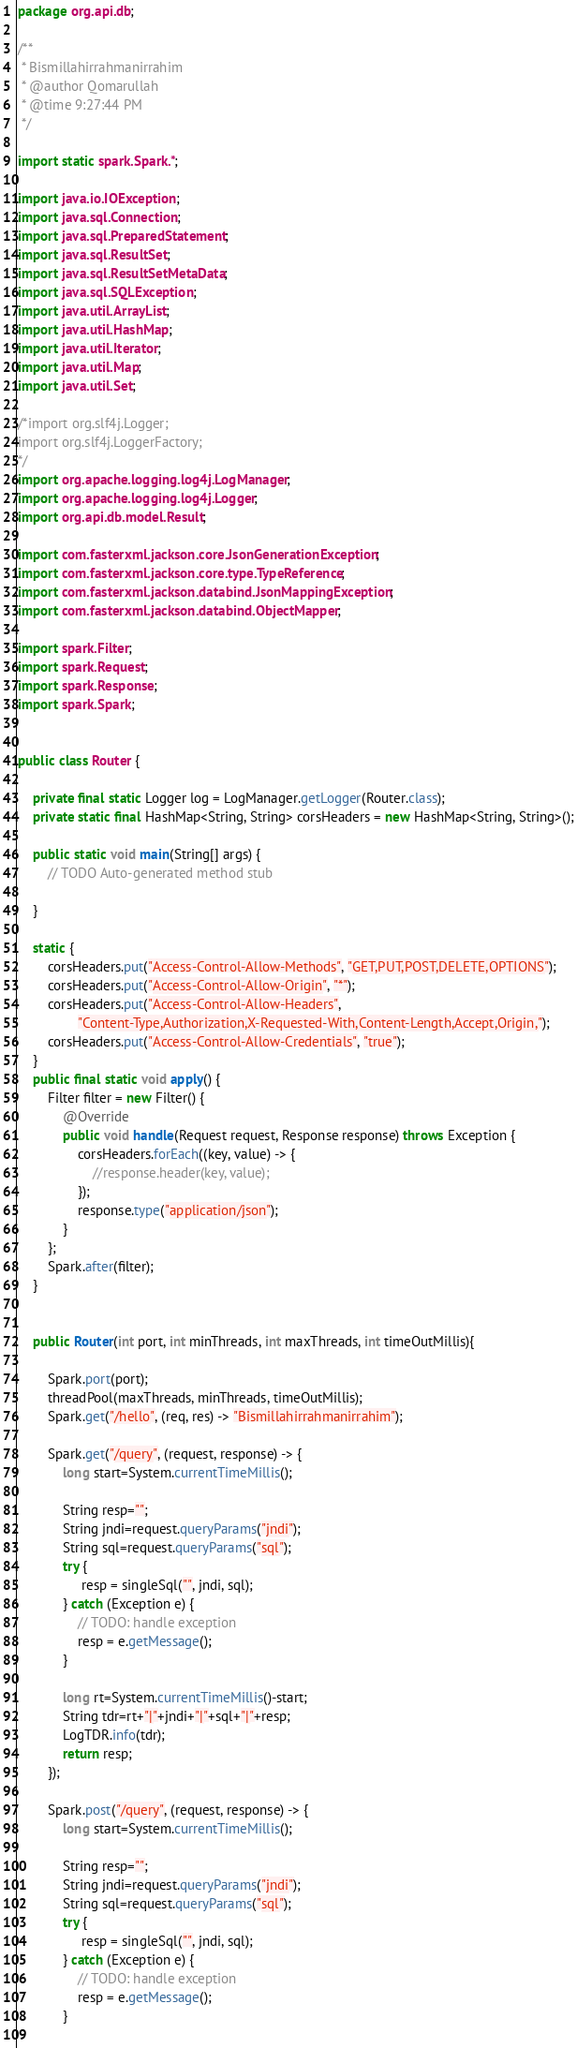Convert code to text. <code><loc_0><loc_0><loc_500><loc_500><_Java_>package org.api.db;

/**
 * Bismillahirrahmanirrahim
 * @author Qomarullah
 * @time 9:27:44 PM
 */

import static spark.Spark.*;

import java.io.IOException;
import java.sql.Connection;
import java.sql.PreparedStatement;
import java.sql.ResultSet;
import java.sql.ResultSetMetaData;
import java.sql.SQLException;
import java.util.ArrayList;
import java.util.HashMap;
import java.util.Iterator;
import java.util.Map;
import java.util.Set;

/*import org.slf4j.Logger;
import org.slf4j.LoggerFactory;
*/
import org.apache.logging.log4j.LogManager;
import org.apache.logging.log4j.Logger;
import org.api.db.model.Result;

import com.fasterxml.jackson.core.JsonGenerationException;
import com.fasterxml.jackson.core.type.TypeReference;
import com.fasterxml.jackson.databind.JsonMappingException;
import com.fasterxml.jackson.databind.ObjectMapper;

import spark.Filter;
import spark.Request;
import spark.Response;
import spark.Spark;


public class Router {

	private final static Logger log = LogManager.getLogger(Router.class);
	private static final HashMap<String, String> corsHeaders = new HashMap<String, String>();

	public static void main(String[] args) {
		// TODO Auto-generated method stub
		
	}
	
	static {
		corsHeaders.put("Access-Control-Allow-Methods", "GET,PUT,POST,DELETE,OPTIONS");
		corsHeaders.put("Access-Control-Allow-Origin", "*");
		corsHeaders.put("Access-Control-Allow-Headers",
				"Content-Type,Authorization,X-Requested-With,Content-Length,Accept,Origin,");
		corsHeaders.put("Access-Control-Allow-Credentials", "true");
	}
	public final static void apply() {
		Filter filter = new Filter() {
			@Override
			public void handle(Request request, Response response) throws Exception {
				corsHeaders.forEach((key, value) -> {
					//response.header(key, value);
				});
				response.type("application/json");
			}
		};
		Spark.after(filter);
	}
	

	public Router(int port, int minThreads, int maxThreads, int timeOutMillis){
		
		Spark.port(port);
		threadPool(maxThreads, minThreads, timeOutMillis);
		Spark.get("/hello", (req, res) -> "Bismillahirrahmanirrahim");
		
		Spark.get("/query", (request, response) -> {
			long start=System.currentTimeMillis();
			
			String resp="";
			String jndi=request.queryParams("jndi");
			String sql=request.queryParams("sql");
		    try {
		    	 resp = singleSql("", jndi, sql);	
			} catch (Exception e) {
				// TODO: handle exception
				resp = e.getMessage();
			}
		   
		    long rt=System.currentTimeMillis()-start;
			String tdr=rt+"|"+jndi+"|"+sql+"|"+resp;
			LogTDR.info(tdr);
		    return resp;
		});
		
		Spark.post("/query", (request, response) -> {
			long start=System.currentTimeMillis();
			
			String resp="";
			String jndi=request.queryParams("jndi");
			String sql=request.queryParams("sql");
		    try {
		    	 resp = singleSql("", jndi, sql);	
			} catch (Exception e) {
				// TODO: handle exception
				resp = e.getMessage();
			}
		   </code> 